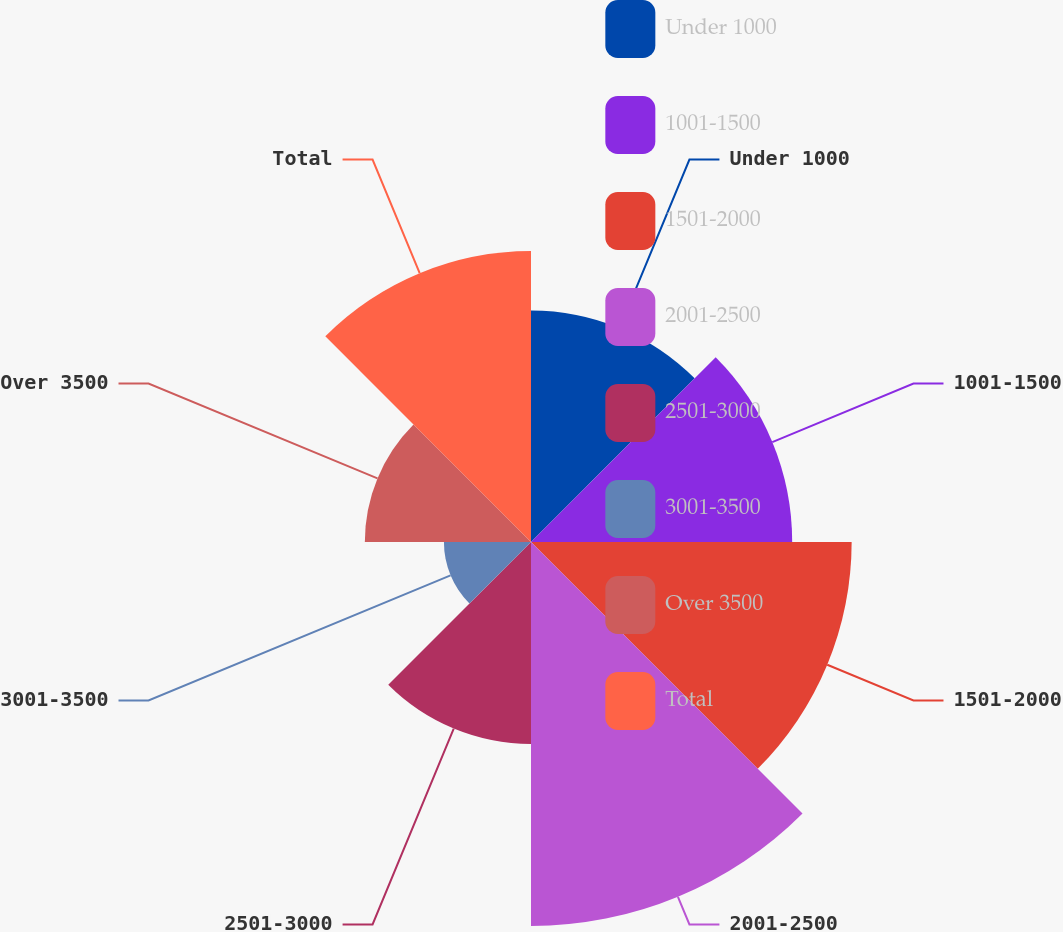Convert chart to OTSL. <chart><loc_0><loc_0><loc_500><loc_500><pie_chart><fcel>Under 1000<fcel>1001-1500<fcel>1501-2000<fcel>2001-2500<fcel>2501-3000<fcel>3001-3500<fcel>Over 3500<fcel>Total<nl><fcel>11.91%<fcel>13.44%<fcel>16.5%<fcel>19.76%<fcel>10.39%<fcel>4.48%<fcel>8.55%<fcel>14.97%<nl></chart> 